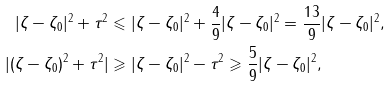<formula> <loc_0><loc_0><loc_500><loc_500>| \zeta - \zeta _ { 0 } | ^ { 2 } + \tau ^ { 2 } & \leqslant | \zeta - \zeta _ { 0 } | ^ { 2 } + \frac { 4 } { 9 } | \zeta - \zeta _ { 0 } | ^ { 2 } = \frac { 1 3 } { 9 } | \zeta - \zeta _ { 0 } | ^ { 2 } , \\ | ( \zeta - \zeta _ { 0 } ) ^ { 2 } + \tau ^ { 2 } | & \geqslant | \zeta - \zeta _ { 0 } | ^ { 2 } - \tau ^ { 2 } \geqslant \frac { 5 } { 9 } | \zeta - \zeta _ { 0 } | ^ { 2 } ,</formula> 